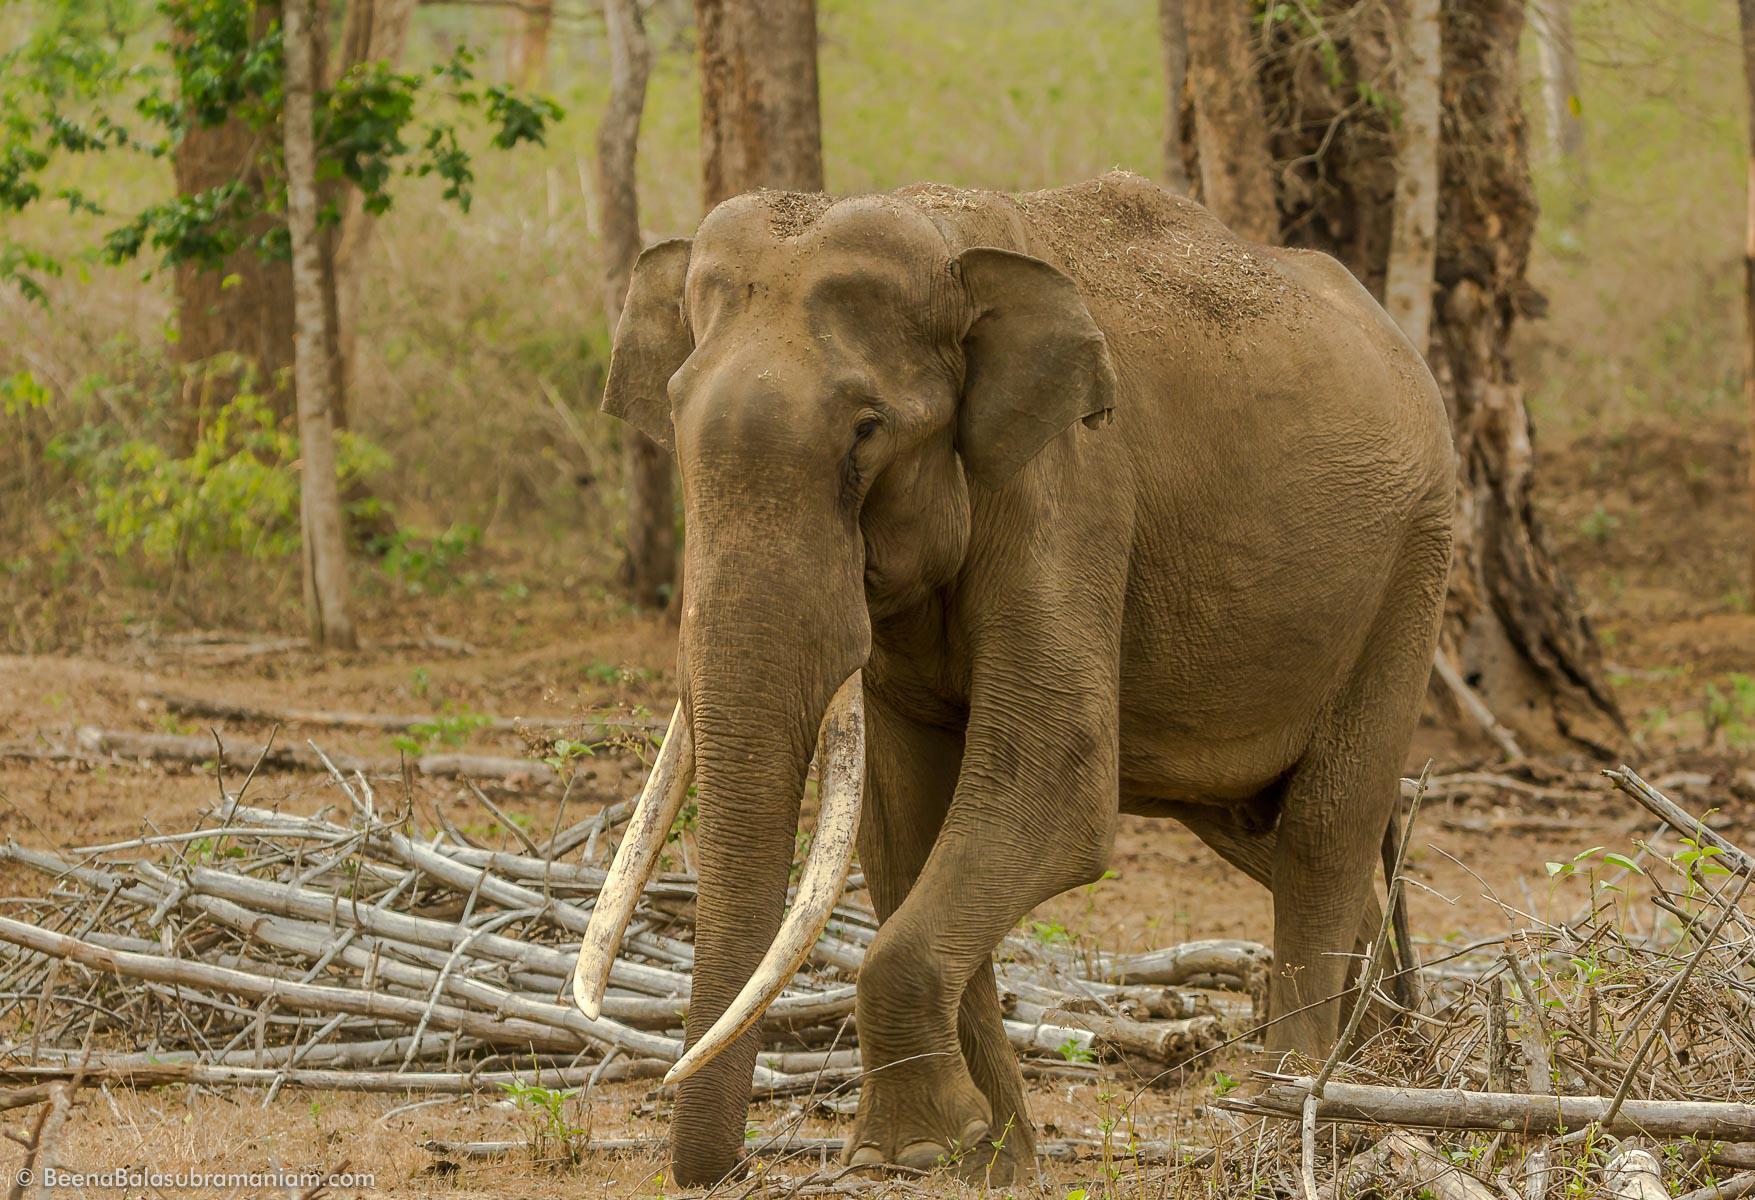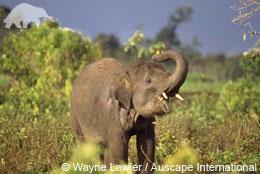The first image is the image on the left, the second image is the image on the right. For the images shown, is this caption "Exactly two elephants are shown, one with its trunk hanging down, and one with its trunk curled up to its head, but both of them with tusks." true? Answer yes or no. Yes. The first image is the image on the left, the second image is the image on the right. Evaluate the accuracy of this statement regarding the images: "One image features an elephant with tusks and a lowered trunk, and the other shows an elephant with tusks and a raised curled trunk.". Is it true? Answer yes or no. Yes. 